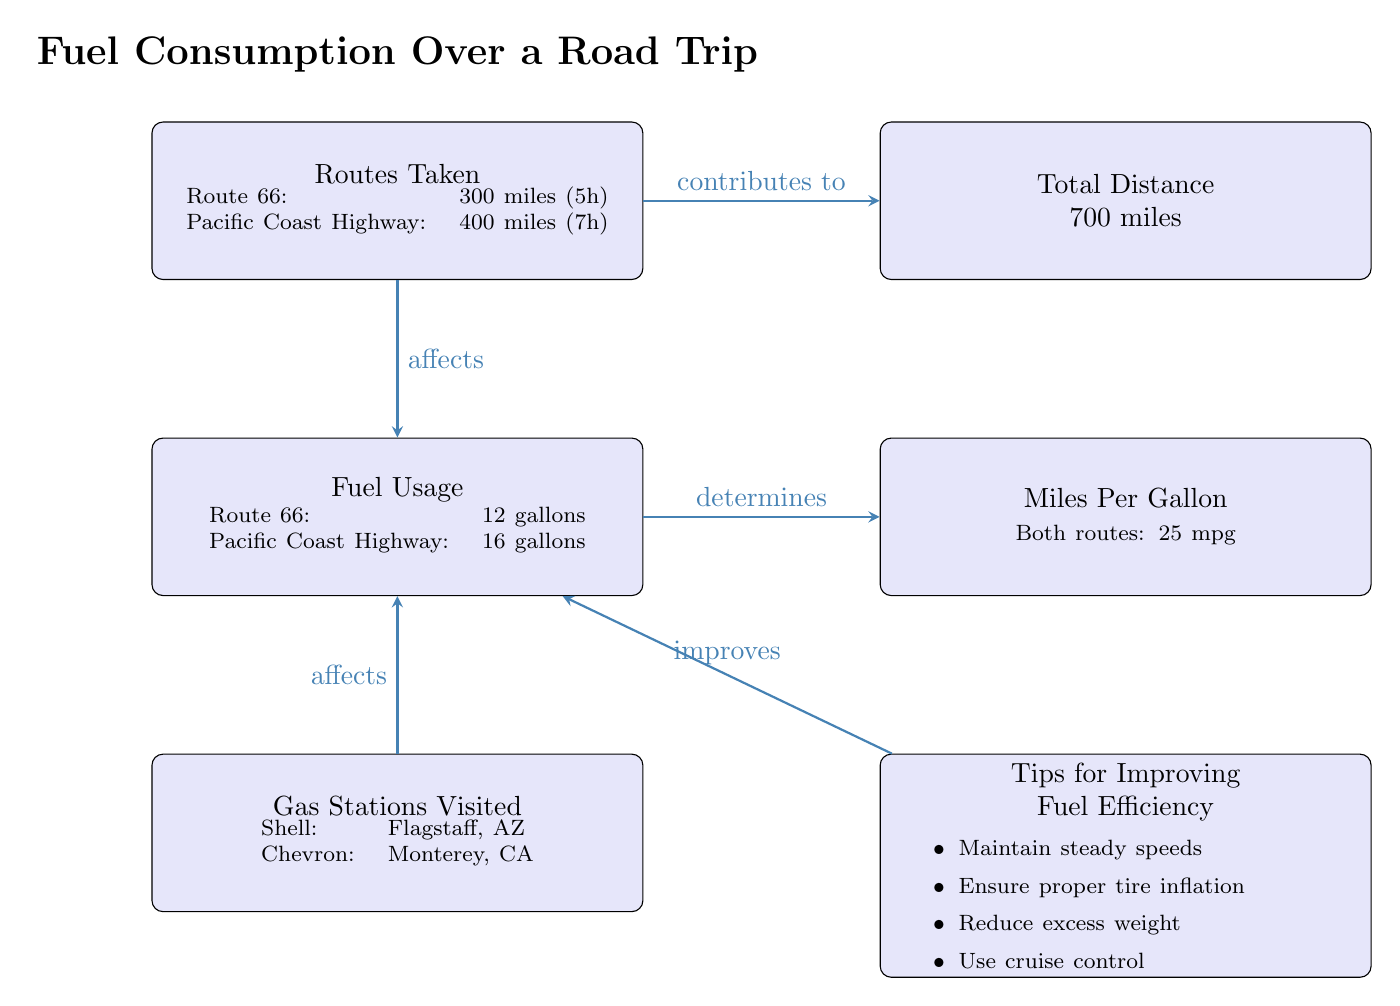What are the two routes taken? From the "Routes Taken" node, we find the listed routes: Route 66 and the Pacific Coast Highway.
Answer: Route 66, Pacific Coast Highway How many gallons of fuel were used on Route 66? The "Fuel Usage" node indicates that Route 66 required 12 gallons of fuel.
Answer: 12 gallons What is the total distance traveled? The "Total Distance" node shows that the combined distance of the two routes is 700 miles.
Answer: 700 miles What is the miles per gallon for both routes? The "Miles Per Gallon" node specifies that both routes achieved 25 miles per gallon.
Answer: 25 mpg Which gas station was visited in Flagstaff, AZ? The "Gas Stations Visited" node identifies Shell as the gas station in Flagstaff, AZ.
Answer: Shell If proper tire inflation improves fuel efficiency, what relationship does this have with fuel usage? The "Tips for Improving Fuel Efficiency" node suggests that maintaining proper tire inflation can reduce fuel usage, which indicates a direct relationship affecting fuel consumption.
Answer: Improves Which route used more gallons of fuel? By comparing the fuel usage for both routes in the "Fuel Usage" node, we see that the Pacific Coast Highway used 16 gallons, which is more than the 12 gallons for Route 66.
Answer: Pacific Coast Highway How many gas stations were visited in total? The "Gas Stations Visited" node lists Shell and Chevron, meaning two gas stations were visited during the trip.
Answer: 2 Which tip is mentioned to help improve fuel efficiency? The "Tips for Improving Fuel Efficiency" node provides several tips, including the suggestion to "Maintain steady speeds."
Answer: Maintain steady speeds 